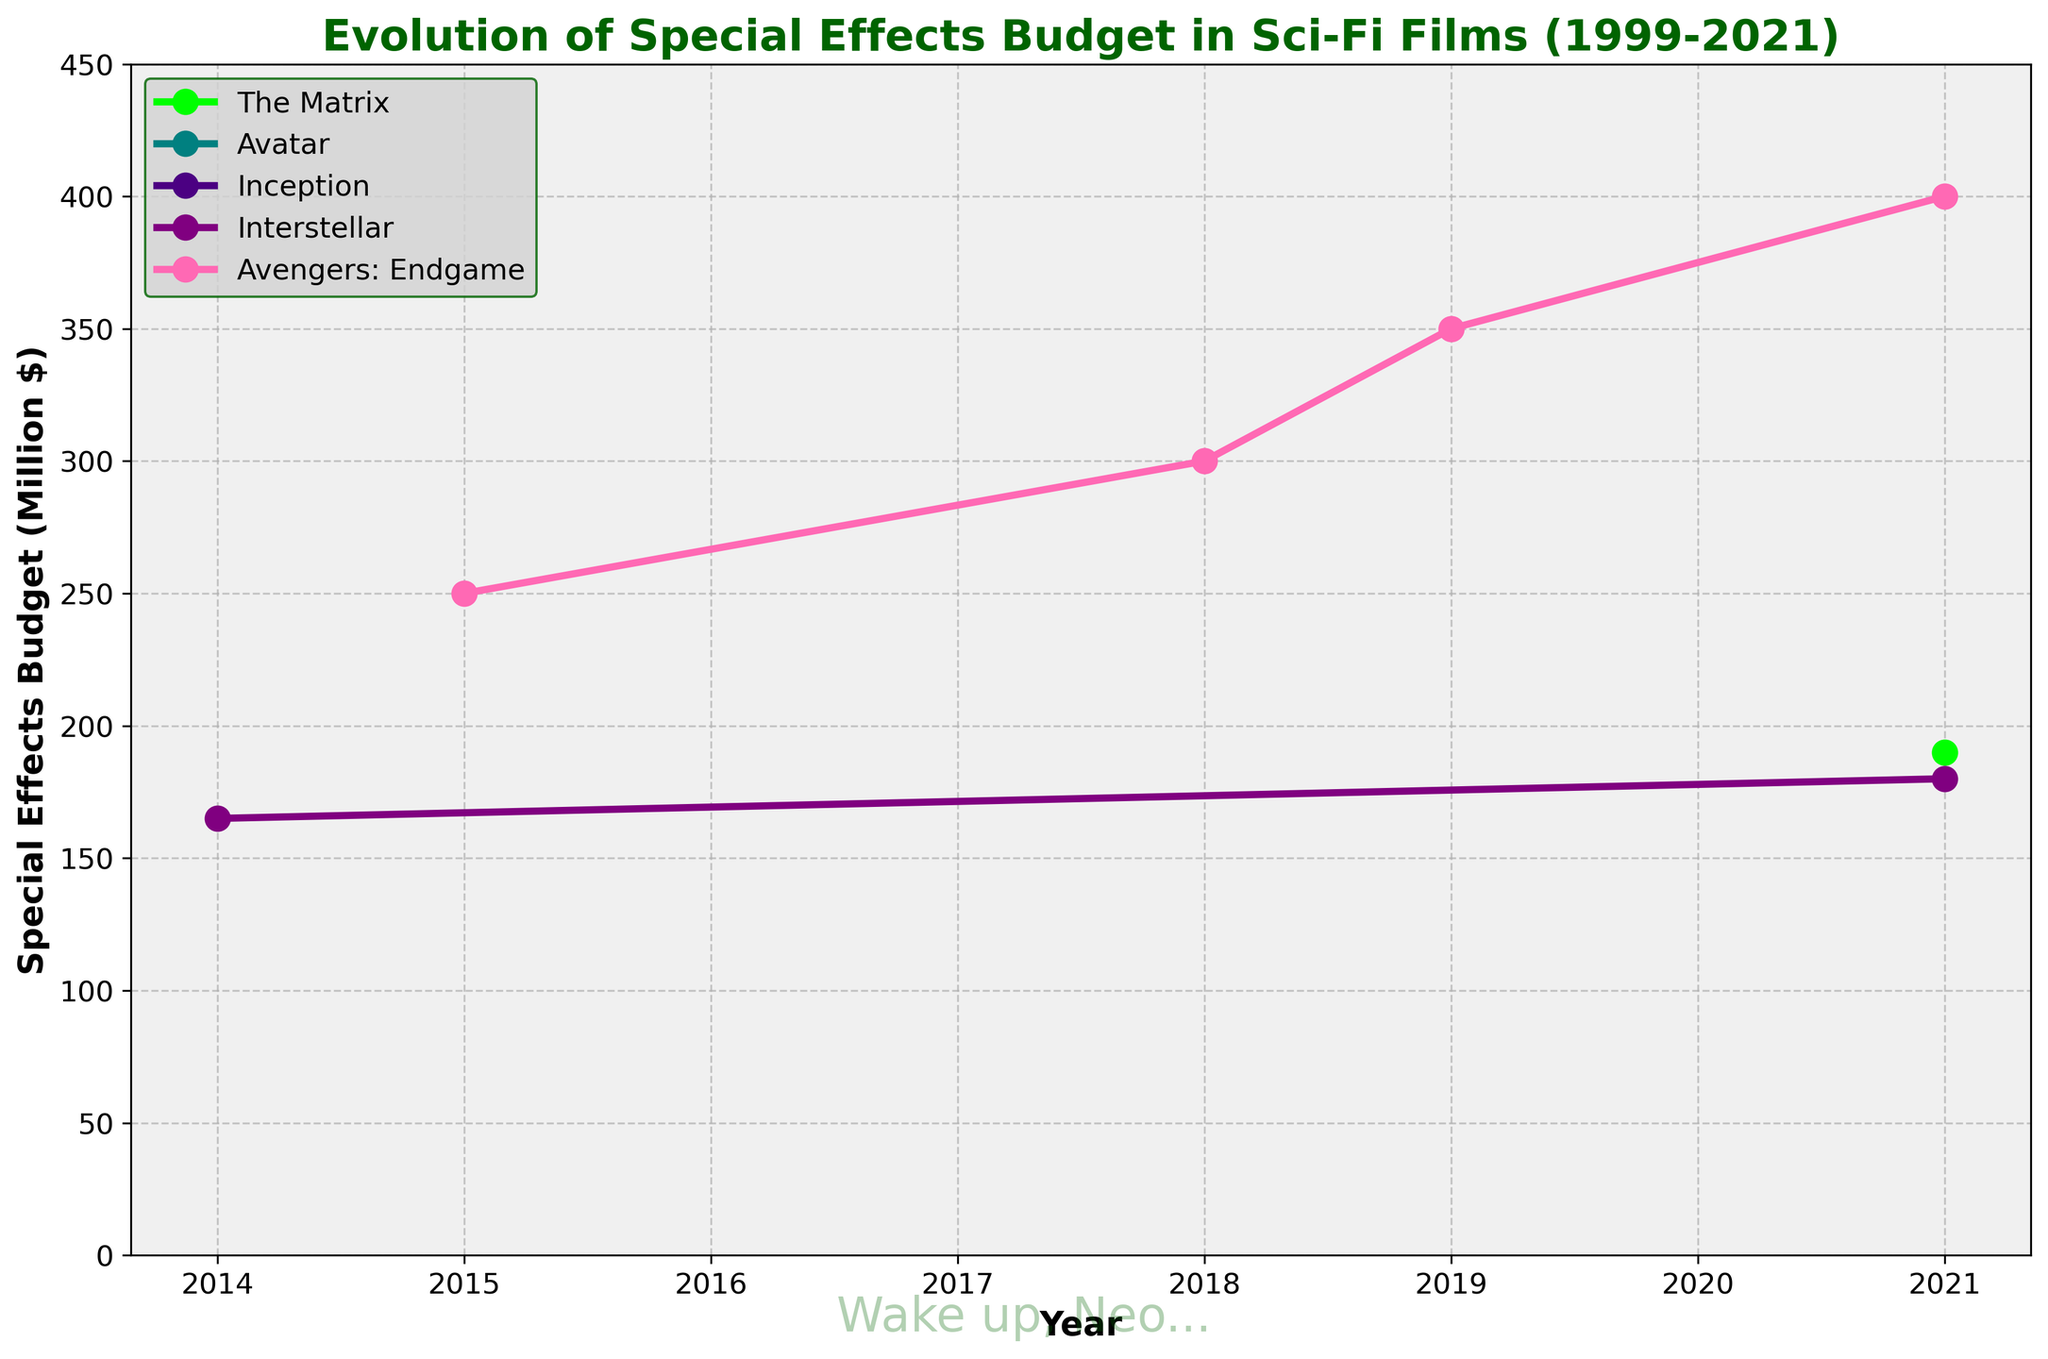What's the special effects budget for 'The Matrix' in 2021? Look at the point corresponding to 'The Matrix' on the line chart for the year 2021. It is marked with a dot.
Answer: 190 How much did the special effects budget for 'Interstellar' cost in 2014? Refer to the point of 'Interstellar' for the year 2014. It is visually marked on the line.
Answer: 165 Which film had the highest special effects budget in 2021? Check the labels on the line graph for the year 2021. Identify the highest point among all.
Answer: Avengers: Endgame What is the combined special effects budget for 'Avatar' and 'Inception' in any year? The dataset doesn't provide such data points for these movies; hence, it's a trick question.
Answer: Data not available Did 'Avengers: Endgame' consistently increase in special effects budget from 2015 to 2021? Observe the trend of the 'Avengers: Endgame' line from 2015 to 2021. It shows an increasing budget every year.
Answer: Yes What is the difference in the special effects budget between 'The Matrix' in 2021 and 'Interstellar' in 2014? Calculate the difference: 190 (The Matrix, 2021) - 165 (Interstellar, 2014).
Answer: 25 Which film's special effects budget has the least amount of data points marked on the chart? Identify the line with the fewest markers (dots).
Answer: Avatar and Inception (since no data for them) How much did the special effects budget for 'Inception' change over the years? Direct inspection suggests 'Inception' has no marked data, implying no available data points to discern any change.
Answer: No data What are the visual aspects that represent 'Avengers: Endgame' budget over the years? The line for 'Avengers: Endgame' is marked by colored dots showing the yearly budget increments.
Answer: Increasing green line with multiple points Which movie had a budget increase of 50 million dollars between 2018 and 2019? 'Avengers: Endgame' shows an increase from 300 million in 2018 to 350 million in 2019.
Answer: Avengers: Endgame 